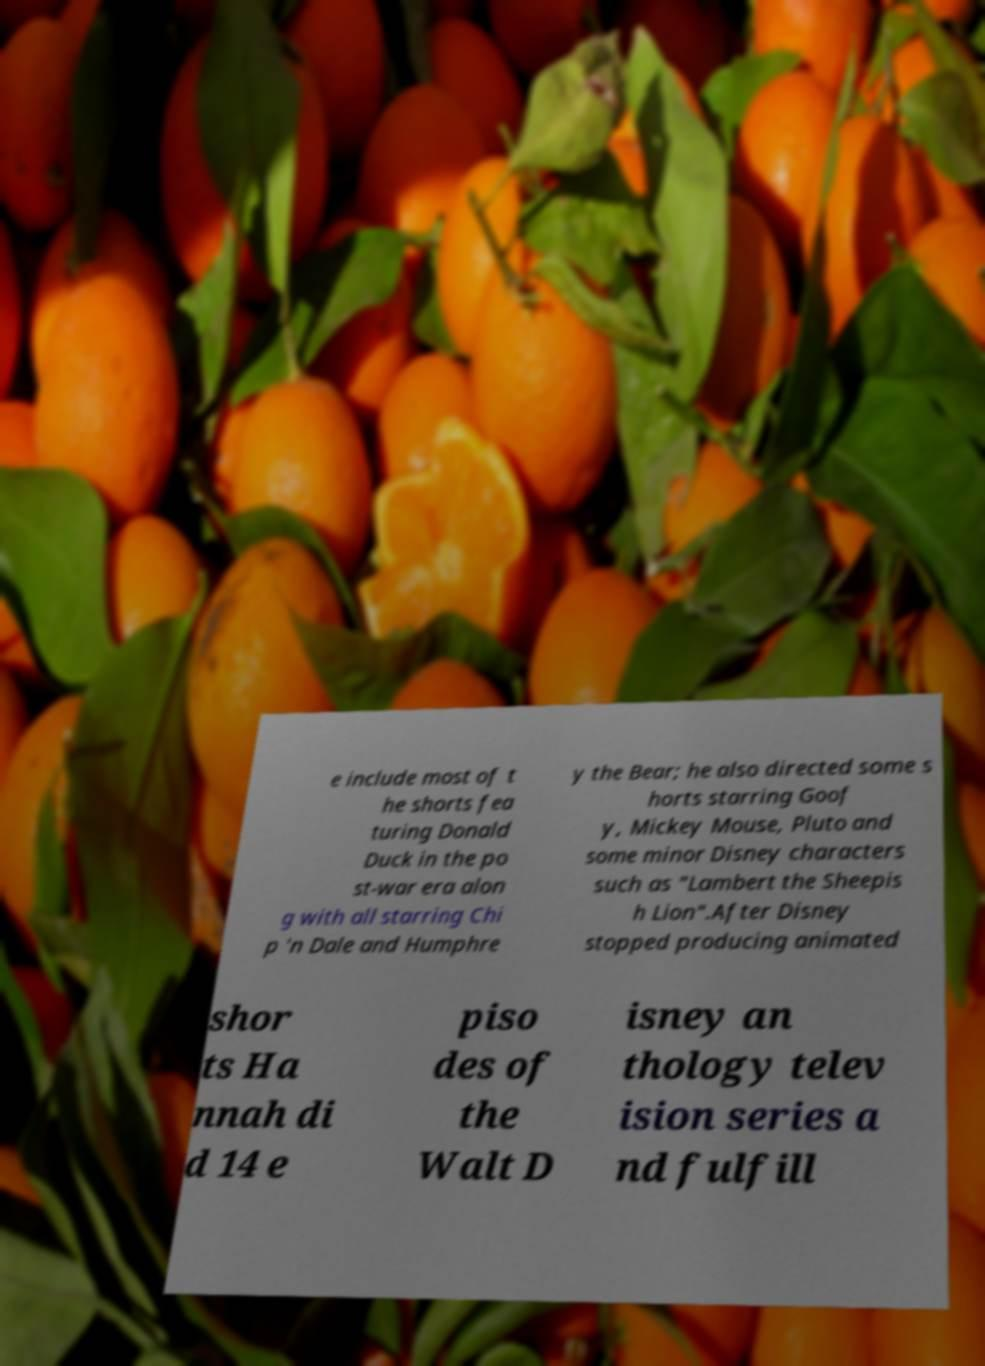Please read and relay the text visible in this image. What does it say? e include most of t he shorts fea turing Donald Duck in the po st-war era alon g with all starring Chi p 'n Dale and Humphre y the Bear; he also directed some s horts starring Goof y, Mickey Mouse, Pluto and some minor Disney characters such as "Lambert the Sheepis h Lion".After Disney stopped producing animated shor ts Ha nnah di d 14 e piso des of the Walt D isney an thology telev ision series a nd fulfill 